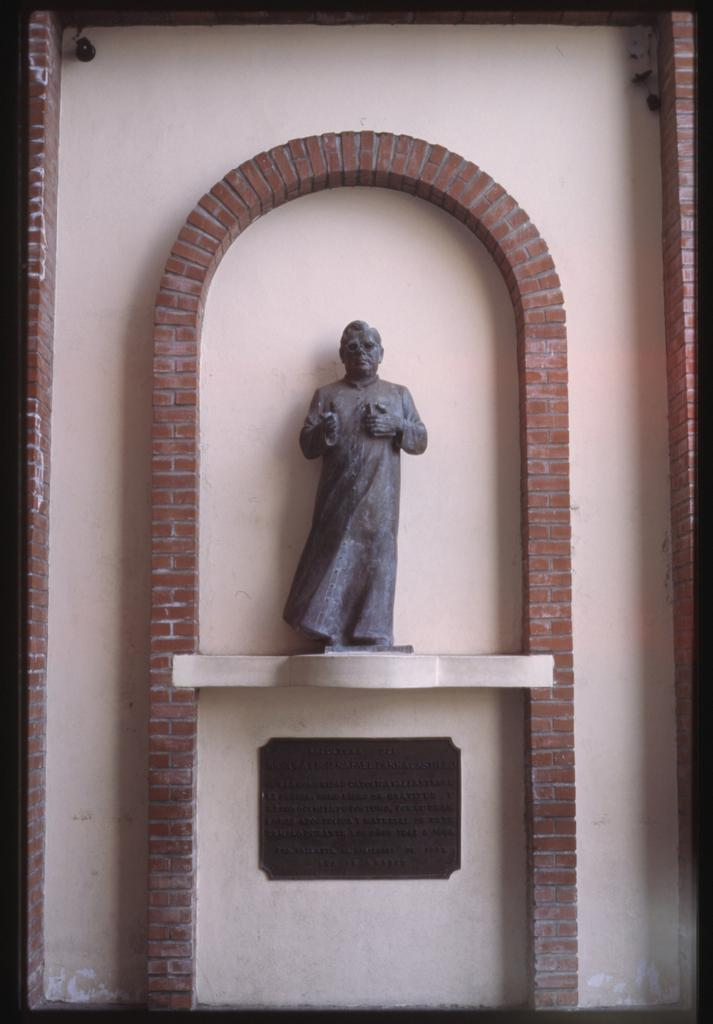What is the main subject of the image? There is a statue of a person in the image. What is the statue standing on? The statue is on a marble base. What is attached to the wall below the marble base? There is a board on the wall below the marble base. How is the wall decorated around the statue? The wall has a brick design around the statue. What type of cap is the statue wearing in the image? The statue does not have a cap, as it is a statue and not a living person. 